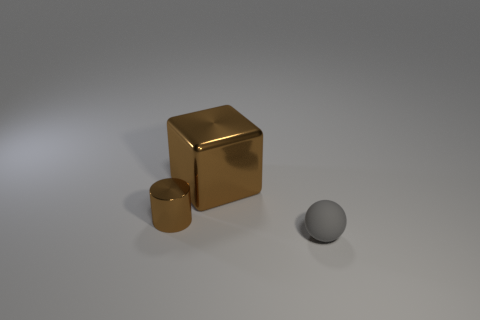Subtract 1 cylinders. How many cylinders are left? 0 Subtract all cylinders. How many objects are left? 2 Add 3 large metallic blocks. How many objects exist? 6 Subtract 0 blue cylinders. How many objects are left? 3 Subtract all red cylinders. Subtract all purple cubes. How many cylinders are left? 1 Subtract all cyan spheres. How many blue blocks are left? 0 Subtract all small gray metallic things. Subtract all cylinders. How many objects are left? 2 Add 1 brown things. How many brown things are left? 3 Add 1 big purple rubber balls. How many big purple rubber balls exist? 1 